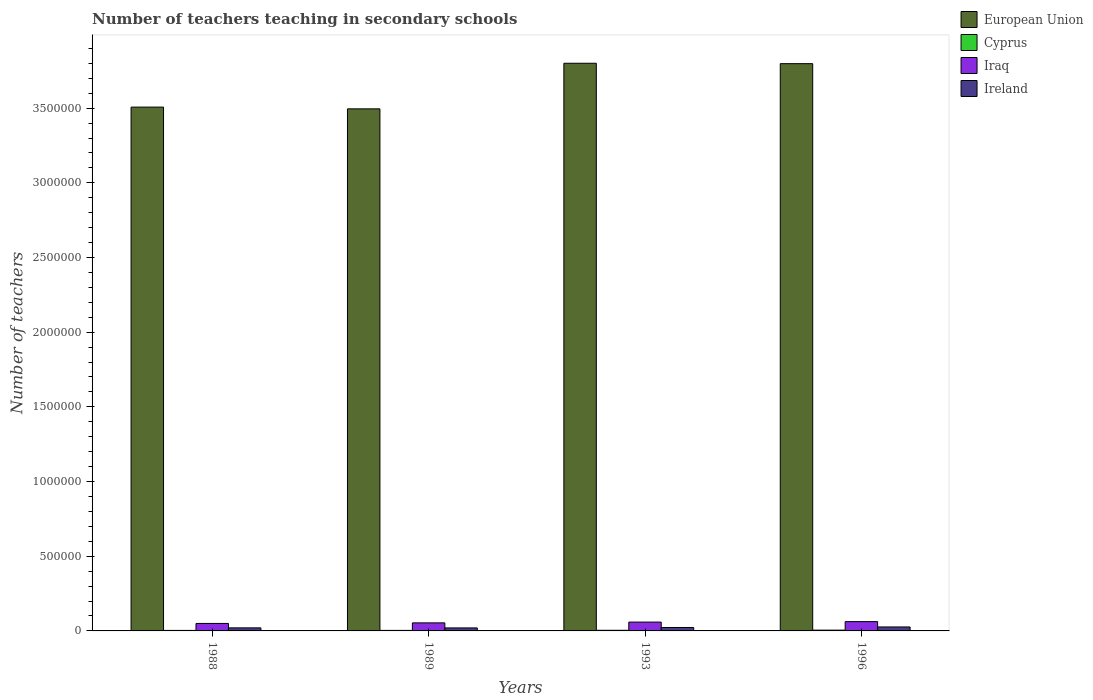How many different coloured bars are there?
Your answer should be very brief. 4. How many groups of bars are there?
Provide a succinct answer. 4. Are the number of bars per tick equal to the number of legend labels?
Your answer should be compact. Yes. Are the number of bars on each tick of the X-axis equal?
Offer a very short reply. Yes. How many bars are there on the 3rd tick from the left?
Offer a very short reply. 4. What is the label of the 4th group of bars from the left?
Ensure brevity in your answer.  1996. In how many cases, is the number of bars for a given year not equal to the number of legend labels?
Your answer should be very brief. 0. What is the number of teachers teaching in secondary schools in Iraq in 1993?
Your answer should be very brief. 5.91e+04. Across all years, what is the maximum number of teachers teaching in secondary schools in Ireland?
Make the answer very short. 2.65e+04. Across all years, what is the minimum number of teachers teaching in secondary schools in Iraq?
Your answer should be compact. 5.01e+04. In which year was the number of teachers teaching in secondary schools in Ireland minimum?
Offer a very short reply. 1989. What is the total number of teachers teaching in secondary schools in Iraq in the graph?
Your response must be concise. 2.25e+05. What is the difference between the number of teachers teaching in secondary schools in Iraq in 1993 and that in 1996?
Provide a succinct answer. -3179. What is the difference between the number of teachers teaching in secondary schools in Ireland in 1988 and the number of teachers teaching in secondary schools in Iraq in 1993?
Your answer should be compact. -3.86e+04. What is the average number of teachers teaching in secondary schools in Iraq per year?
Offer a very short reply. 5.64e+04. In the year 1993, what is the difference between the number of teachers teaching in secondary schools in Cyprus and number of teachers teaching in secondary schools in Ireland?
Offer a very short reply. -1.87e+04. What is the ratio of the number of teachers teaching in secondary schools in European Union in 1993 to that in 1996?
Your answer should be compact. 1. What is the difference between the highest and the second highest number of teachers teaching in secondary schools in Ireland?
Give a very brief answer. 3563. What is the difference between the highest and the lowest number of teachers teaching in secondary schools in Iraq?
Ensure brevity in your answer.  1.22e+04. Is it the case that in every year, the sum of the number of teachers teaching in secondary schools in Iraq and number of teachers teaching in secondary schools in Cyprus is greater than the sum of number of teachers teaching in secondary schools in Ireland and number of teachers teaching in secondary schools in European Union?
Provide a short and direct response. Yes. What does the 1st bar from the left in 1996 represents?
Provide a succinct answer. European Union. What does the 1st bar from the right in 1993 represents?
Give a very brief answer. Ireland. How many years are there in the graph?
Give a very brief answer. 4. What is the difference between two consecutive major ticks on the Y-axis?
Ensure brevity in your answer.  5.00e+05. Does the graph contain any zero values?
Ensure brevity in your answer.  No. Does the graph contain grids?
Provide a short and direct response. No. Where does the legend appear in the graph?
Your response must be concise. Top right. What is the title of the graph?
Provide a succinct answer. Number of teachers teaching in secondary schools. What is the label or title of the X-axis?
Your answer should be very brief. Years. What is the label or title of the Y-axis?
Your answer should be compact. Number of teachers. What is the Number of teachers in European Union in 1988?
Provide a succinct answer. 3.51e+06. What is the Number of teachers of Cyprus in 1988?
Provide a succinct answer. 3407. What is the Number of teachers of Iraq in 1988?
Provide a short and direct response. 5.01e+04. What is the Number of teachers of Ireland in 1988?
Offer a very short reply. 2.05e+04. What is the Number of teachers in European Union in 1989?
Give a very brief answer. 3.50e+06. What is the Number of teachers in Cyprus in 1989?
Your answer should be very brief. 3524. What is the Number of teachers of Iraq in 1989?
Provide a succinct answer. 5.39e+04. What is the Number of teachers of Ireland in 1989?
Provide a succinct answer. 2.01e+04. What is the Number of teachers of European Union in 1993?
Provide a succinct answer. 3.80e+06. What is the Number of teachers of Cyprus in 1993?
Your response must be concise. 4217. What is the Number of teachers in Iraq in 1993?
Provide a short and direct response. 5.91e+04. What is the Number of teachers in Ireland in 1993?
Keep it short and to the point. 2.30e+04. What is the Number of teachers in European Union in 1996?
Offer a very short reply. 3.80e+06. What is the Number of teachers of Cyprus in 1996?
Make the answer very short. 5300. What is the Number of teachers in Iraq in 1996?
Ensure brevity in your answer.  6.23e+04. What is the Number of teachers in Ireland in 1996?
Provide a short and direct response. 2.65e+04. Across all years, what is the maximum Number of teachers in European Union?
Provide a succinct answer. 3.80e+06. Across all years, what is the maximum Number of teachers of Cyprus?
Make the answer very short. 5300. Across all years, what is the maximum Number of teachers of Iraq?
Offer a terse response. 6.23e+04. Across all years, what is the maximum Number of teachers in Ireland?
Provide a succinct answer. 2.65e+04. Across all years, what is the minimum Number of teachers in European Union?
Provide a short and direct response. 3.50e+06. Across all years, what is the minimum Number of teachers in Cyprus?
Your answer should be very brief. 3407. Across all years, what is the minimum Number of teachers of Iraq?
Offer a very short reply. 5.01e+04. Across all years, what is the minimum Number of teachers in Ireland?
Ensure brevity in your answer.  2.01e+04. What is the total Number of teachers in European Union in the graph?
Make the answer very short. 1.46e+07. What is the total Number of teachers of Cyprus in the graph?
Ensure brevity in your answer.  1.64e+04. What is the total Number of teachers in Iraq in the graph?
Give a very brief answer. 2.25e+05. What is the total Number of teachers in Ireland in the graph?
Your response must be concise. 9.01e+04. What is the difference between the Number of teachers of European Union in 1988 and that in 1989?
Provide a succinct answer. 1.17e+04. What is the difference between the Number of teachers of Cyprus in 1988 and that in 1989?
Give a very brief answer. -117. What is the difference between the Number of teachers of Iraq in 1988 and that in 1989?
Provide a short and direct response. -3883. What is the difference between the Number of teachers of Ireland in 1988 and that in 1989?
Offer a terse response. 381. What is the difference between the Number of teachers of European Union in 1988 and that in 1993?
Your answer should be compact. -2.94e+05. What is the difference between the Number of teachers in Cyprus in 1988 and that in 1993?
Your answer should be compact. -810. What is the difference between the Number of teachers of Iraq in 1988 and that in 1993?
Provide a short and direct response. -9063. What is the difference between the Number of teachers in Ireland in 1988 and that in 1993?
Make the answer very short. -2485. What is the difference between the Number of teachers of European Union in 1988 and that in 1996?
Your response must be concise. -2.91e+05. What is the difference between the Number of teachers in Cyprus in 1988 and that in 1996?
Your response must be concise. -1893. What is the difference between the Number of teachers of Iraq in 1988 and that in 1996?
Your response must be concise. -1.22e+04. What is the difference between the Number of teachers in Ireland in 1988 and that in 1996?
Offer a terse response. -6048. What is the difference between the Number of teachers of European Union in 1989 and that in 1993?
Your answer should be very brief. -3.05e+05. What is the difference between the Number of teachers in Cyprus in 1989 and that in 1993?
Provide a succinct answer. -693. What is the difference between the Number of teachers in Iraq in 1989 and that in 1993?
Provide a short and direct response. -5180. What is the difference between the Number of teachers in Ireland in 1989 and that in 1993?
Keep it short and to the point. -2866. What is the difference between the Number of teachers of European Union in 1989 and that in 1996?
Your answer should be very brief. -3.03e+05. What is the difference between the Number of teachers of Cyprus in 1989 and that in 1996?
Make the answer very short. -1776. What is the difference between the Number of teachers of Iraq in 1989 and that in 1996?
Your answer should be compact. -8359. What is the difference between the Number of teachers in Ireland in 1989 and that in 1996?
Provide a short and direct response. -6429. What is the difference between the Number of teachers in European Union in 1993 and that in 1996?
Provide a succinct answer. 2699.25. What is the difference between the Number of teachers of Cyprus in 1993 and that in 1996?
Provide a short and direct response. -1083. What is the difference between the Number of teachers of Iraq in 1993 and that in 1996?
Your answer should be very brief. -3179. What is the difference between the Number of teachers of Ireland in 1993 and that in 1996?
Your answer should be very brief. -3563. What is the difference between the Number of teachers in European Union in 1988 and the Number of teachers in Cyprus in 1989?
Your response must be concise. 3.50e+06. What is the difference between the Number of teachers of European Union in 1988 and the Number of teachers of Iraq in 1989?
Provide a short and direct response. 3.45e+06. What is the difference between the Number of teachers in European Union in 1988 and the Number of teachers in Ireland in 1989?
Make the answer very short. 3.49e+06. What is the difference between the Number of teachers of Cyprus in 1988 and the Number of teachers of Iraq in 1989?
Offer a terse response. -5.05e+04. What is the difference between the Number of teachers in Cyprus in 1988 and the Number of teachers in Ireland in 1989?
Your response must be concise. -1.67e+04. What is the difference between the Number of teachers in Iraq in 1988 and the Number of teachers in Ireland in 1989?
Give a very brief answer. 3.00e+04. What is the difference between the Number of teachers of European Union in 1988 and the Number of teachers of Cyprus in 1993?
Your response must be concise. 3.50e+06. What is the difference between the Number of teachers of European Union in 1988 and the Number of teachers of Iraq in 1993?
Offer a terse response. 3.45e+06. What is the difference between the Number of teachers in European Union in 1988 and the Number of teachers in Ireland in 1993?
Your answer should be very brief. 3.48e+06. What is the difference between the Number of teachers of Cyprus in 1988 and the Number of teachers of Iraq in 1993?
Offer a terse response. -5.57e+04. What is the difference between the Number of teachers in Cyprus in 1988 and the Number of teachers in Ireland in 1993?
Offer a terse response. -1.96e+04. What is the difference between the Number of teachers of Iraq in 1988 and the Number of teachers of Ireland in 1993?
Ensure brevity in your answer.  2.71e+04. What is the difference between the Number of teachers in European Union in 1988 and the Number of teachers in Cyprus in 1996?
Keep it short and to the point. 3.50e+06. What is the difference between the Number of teachers of European Union in 1988 and the Number of teachers of Iraq in 1996?
Your response must be concise. 3.44e+06. What is the difference between the Number of teachers of European Union in 1988 and the Number of teachers of Ireland in 1996?
Offer a terse response. 3.48e+06. What is the difference between the Number of teachers in Cyprus in 1988 and the Number of teachers in Iraq in 1996?
Your answer should be very brief. -5.89e+04. What is the difference between the Number of teachers in Cyprus in 1988 and the Number of teachers in Ireland in 1996?
Keep it short and to the point. -2.31e+04. What is the difference between the Number of teachers of Iraq in 1988 and the Number of teachers of Ireland in 1996?
Offer a terse response. 2.35e+04. What is the difference between the Number of teachers in European Union in 1989 and the Number of teachers in Cyprus in 1993?
Keep it short and to the point. 3.49e+06. What is the difference between the Number of teachers in European Union in 1989 and the Number of teachers in Iraq in 1993?
Offer a very short reply. 3.44e+06. What is the difference between the Number of teachers in European Union in 1989 and the Number of teachers in Ireland in 1993?
Ensure brevity in your answer.  3.47e+06. What is the difference between the Number of teachers in Cyprus in 1989 and the Number of teachers in Iraq in 1993?
Keep it short and to the point. -5.56e+04. What is the difference between the Number of teachers in Cyprus in 1989 and the Number of teachers in Ireland in 1993?
Make the answer very short. -1.94e+04. What is the difference between the Number of teachers of Iraq in 1989 and the Number of teachers of Ireland in 1993?
Keep it short and to the point. 3.10e+04. What is the difference between the Number of teachers in European Union in 1989 and the Number of teachers in Cyprus in 1996?
Give a very brief answer. 3.49e+06. What is the difference between the Number of teachers of European Union in 1989 and the Number of teachers of Iraq in 1996?
Offer a very short reply. 3.43e+06. What is the difference between the Number of teachers in European Union in 1989 and the Number of teachers in Ireland in 1996?
Give a very brief answer. 3.47e+06. What is the difference between the Number of teachers of Cyprus in 1989 and the Number of teachers of Iraq in 1996?
Your answer should be very brief. -5.88e+04. What is the difference between the Number of teachers in Cyprus in 1989 and the Number of teachers in Ireland in 1996?
Provide a succinct answer. -2.30e+04. What is the difference between the Number of teachers of Iraq in 1989 and the Number of teachers of Ireland in 1996?
Keep it short and to the point. 2.74e+04. What is the difference between the Number of teachers in European Union in 1993 and the Number of teachers in Cyprus in 1996?
Ensure brevity in your answer.  3.80e+06. What is the difference between the Number of teachers in European Union in 1993 and the Number of teachers in Iraq in 1996?
Keep it short and to the point. 3.74e+06. What is the difference between the Number of teachers of European Union in 1993 and the Number of teachers of Ireland in 1996?
Give a very brief answer. 3.77e+06. What is the difference between the Number of teachers in Cyprus in 1993 and the Number of teachers in Iraq in 1996?
Provide a short and direct response. -5.81e+04. What is the difference between the Number of teachers of Cyprus in 1993 and the Number of teachers of Ireland in 1996?
Keep it short and to the point. -2.23e+04. What is the difference between the Number of teachers of Iraq in 1993 and the Number of teachers of Ireland in 1996?
Provide a succinct answer. 3.26e+04. What is the average Number of teachers in European Union per year?
Provide a succinct answer. 3.65e+06. What is the average Number of teachers in Cyprus per year?
Your answer should be very brief. 4112. What is the average Number of teachers of Iraq per year?
Provide a succinct answer. 5.64e+04. What is the average Number of teachers of Ireland per year?
Make the answer very short. 2.25e+04. In the year 1988, what is the difference between the Number of teachers in European Union and Number of teachers in Cyprus?
Offer a very short reply. 3.50e+06. In the year 1988, what is the difference between the Number of teachers in European Union and Number of teachers in Iraq?
Make the answer very short. 3.46e+06. In the year 1988, what is the difference between the Number of teachers in European Union and Number of teachers in Ireland?
Your answer should be compact. 3.49e+06. In the year 1988, what is the difference between the Number of teachers in Cyprus and Number of teachers in Iraq?
Provide a short and direct response. -4.66e+04. In the year 1988, what is the difference between the Number of teachers in Cyprus and Number of teachers in Ireland?
Your answer should be very brief. -1.71e+04. In the year 1988, what is the difference between the Number of teachers in Iraq and Number of teachers in Ireland?
Keep it short and to the point. 2.96e+04. In the year 1989, what is the difference between the Number of teachers in European Union and Number of teachers in Cyprus?
Provide a short and direct response. 3.49e+06. In the year 1989, what is the difference between the Number of teachers in European Union and Number of teachers in Iraq?
Provide a short and direct response. 3.44e+06. In the year 1989, what is the difference between the Number of teachers of European Union and Number of teachers of Ireland?
Give a very brief answer. 3.48e+06. In the year 1989, what is the difference between the Number of teachers in Cyprus and Number of teachers in Iraq?
Provide a succinct answer. -5.04e+04. In the year 1989, what is the difference between the Number of teachers in Cyprus and Number of teachers in Ireland?
Keep it short and to the point. -1.66e+04. In the year 1989, what is the difference between the Number of teachers in Iraq and Number of teachers in Ireland?
Your answer should be compact. 3.38e+04. In the year 1993, what is the difference between the Number of teachers of European Union and Number of teachers of Cyprus?
Give a very brief answer. 3.80e+06. In the year 1993, what is the difference between the Number of teachers in European Union and Number of teachers in Iraq?
Ensure brevity in your answer.  3.74e+06. In the year 1993, what is the difference between the Number of teachers in European Union and Number of teachers in Ireland?
Your answer should be compact. 3.78e+06. In the year 1993, what is the difference between the Number of teachers of Cyprus and Number of teachers of Iraq?
Provide a short and direct response. -5.49e+04. In the year 1993, what is the difference between the Number of teachers of Cyprus and Number of teachers of Ireland?
Offer a terse response. -1.87e+04. In the year 1993, what is the difference between the Number of teachers in Iraq and Number of teachers in Ireland?
Your answer should be very brief. 3.62e+04. In the year 1996, what is the difference between the Number of teachers in European Union and Number of teachers in Cyprus?
Provide a short and direct response. 3.79e+06. In the year 1996, what is the difference between the Number of teachers of European Union and Number of teachers of Iraq?
Give a very brief answer. 3.74e+06. In the year 1996, what is the difference between the Number of teachers of European Union and Number of teachers of Ireland?
Provide a short and direct response. 3.77e+06. In the year 1996, what is the difference between the Number of teachers in Cyprus and Number of teachers in Iraq?
Give a very brief answer. -5.70e+04. In the year 1996, what is the difference between the Number of teachers of Cyprus and Number of teachers of Ireland?
Your answer should be very brief. -2.12e+04. In the year 1996, what is the difference between the Number of teachers in Iraq and Number of teachers in Ireland?
Ensure brevity in your answer.  3.58e+04. What is the ratio of the Number of teachers of European Union in 1988 to that in 1989?
Your response must be concise. 1. What is the ratio of the Number of teachers of Cyprus in 1988 to that in 1989?
Your answer should be compact. 0.97. What is the ratio of the Number of teachers in Iraq in 1988 to that in 1989?
Ensure brevity in your answer.  0.93. What is the ratio of the Number of teachers in European Union in 1988 to that in 1993?
Make the answer very short. 0.92. What is the ratio of the Number of teachers of Cyprus in 1988 to that in 1993?
Provide a succinct answer. 0.81. What is the ratio of the Number of teachers of Iraq in 1988 to that in 1993?
Ensure brevity in your answer.  0.85. What is the ratio of the Number of teachers of Ireland in 1988 to that in 1993?
Give a very brief answer. 0.89. What is the ratio of the Number of teachers of European Union in 1988 to that in 1996?
Ensure brevity in your answer.  0.92. What is the ratio of the Number of teachers of Cyprus in 1988 to that in 1996?
Ensure brevity in your answer.  0.64. What is the ratio of the Number of teachers of Iraq in 1988 to that in 1996?
Your answer should be compact. 0.8. What is the ratio of the Number of teachers of Ireland in 1988 to that in 1996?
Offer a very short reply. 0.77. What is the ratio of the Number of teachers in European Union in 1989 to that in 1993?
Give a very brief answer. 0.92. What is the ratio of the Number of teachers in Cyprus in 1989 to that in 1993?
Provide a succinct answer. 0.84. What is the ratio of the Number of teachers in Iraq in 1989 to that in 1993?
Give a very brief answer. 0.91. What is the ratio of the Number of teachers in Ireland in 1989 to that in 1993?
Provide a short and direct response. 0.88. What is the ratio of the Number of teachers of European Union in 1989 to that in 1996?
Ensure brevity in your answer.  0.92. What is the ratio of the Number of teachers of Cyprus in 1989 to that in 1996?
Provide a short and direct response. 0.66. What is the ratio of the Number of teachers of Iraq in 1989 to that in 1996?
Ensure brevity in your answer.  0.87. What is the ratio of the Number of teachers of Ireland in 1989 to that in 1996?
Ensure brevity in your answer.  0.76. What is the ratio of the Number of teachers in Cyprus in 1993 to that in 1996?
Provide a succinct answer. 0.8. What is the ratio of the Number of teachers of Iraq in 1993 to that in 1996?
Offer a very short reply. 0.95. What is the ratio of the Number of teachers of Ireland in 1993 to that in 1996?
Your answer should be compact. 0.87. What is the difference between the highest and the second highest Number of teachers in European Union?
Provide a short and direct response. 2699.25. What is the difference between the highest and the second highest Number of teachers in Cyprus?
Provide a short and direct response. 1083. What is the difference between the highest and the second highest Number of teachers of Iraq?
Your answer should be compact. 3179. What is the difference between the highest and the second highest Number of teachers of Ireland?
Provide a succinct answer. 3563. What is the difference between the highest and the lowest Number of teachers of European Union?
Keep it short and to the point. 3.05e+05. What is the difference between the highest and the lowest Number of teachers in Cyprus?
Keep it short and to the point. 1893. What is the difference between the highest and the lowest Number of teachers of Iraq?
Offer a very short reply. 1.22e+04. What is the difference between the highest and the lowest Number of teachers of Ireland?
Offer a very short reply. 6429. 